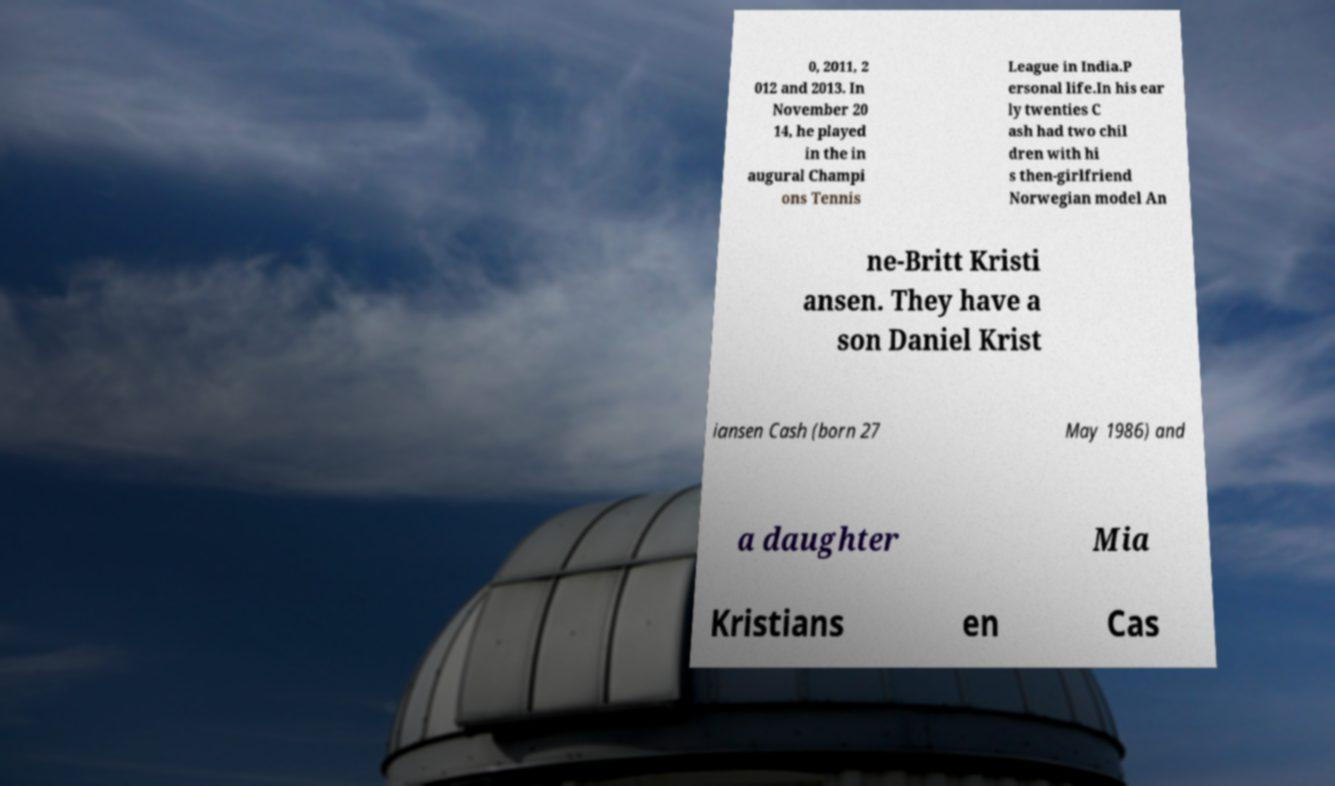Can you accurately transcribe the text from the provided image for me? 0, 2011, 2 012 and 2013. In November 20 14, he played in the in augural Champi ons Tennis League in India.P ersonal life.In his ear ly twenties C ash had two chil dren with hi s then-girlfriend Norwegian model An ne-Britt Kristi ansen. They have a son Daniel Krist iansen Cash (born 27 May 1986) and a daughter Mia Kristians en Cas 